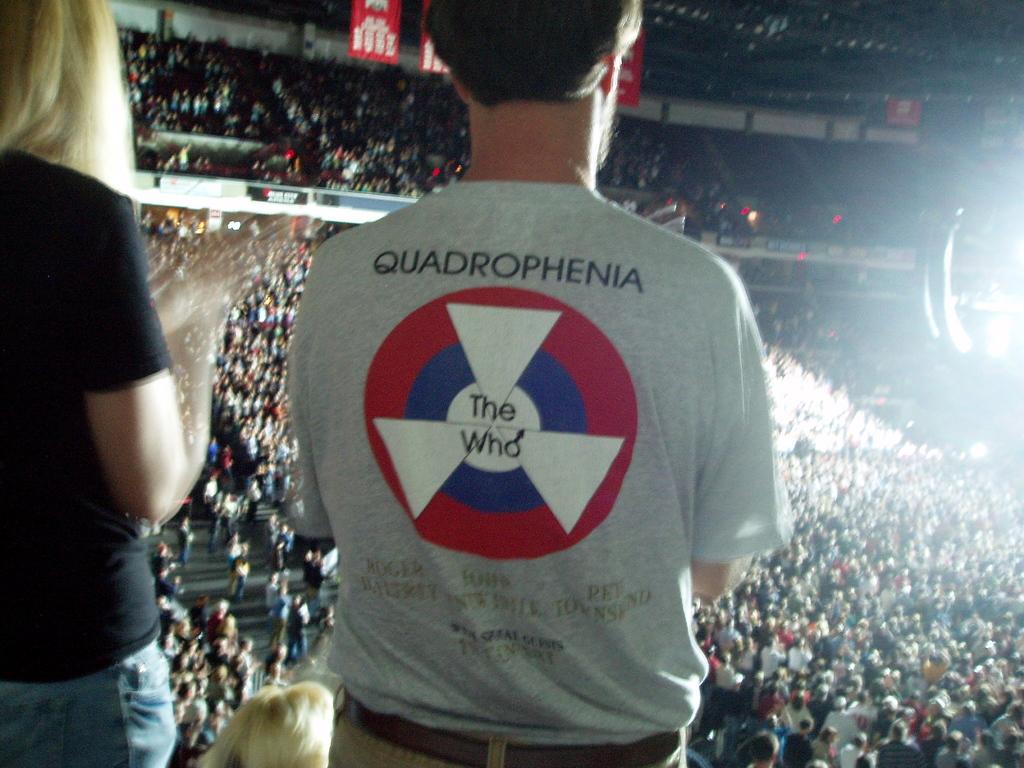What is the word in black lettering at the top of the shirt?
Make the answer very short. Quadrophenia. 